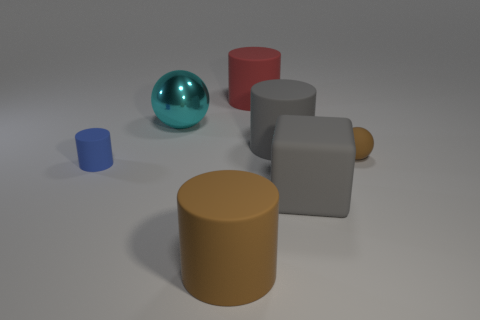Add 1 large brown metallic cubes. How many objects exist? 8 Subtract all cylinders. How many objects are left? 3 Add 6 gray matte cubes. How many gray matte cubes are left? 7 Add 1 small brown balls. How many small brown balls exist? 2 Subtract 0 green cylinders. How many objects are left? 7 Subtract all purple things. Subtract all large red rubber cylinders. How many objects are left? 6 